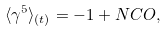Convert formula to latex. <formula><loc_0><loc_0><loc_500><loc_500>\langle \gamma ^ { 5 } \rangle _ { ( t ) } = - 1 + N C O ,</formula> 